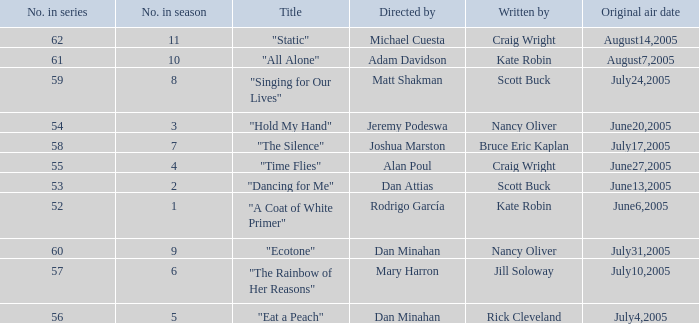What date was episode 10 in the season originally aired? August7,2005. 